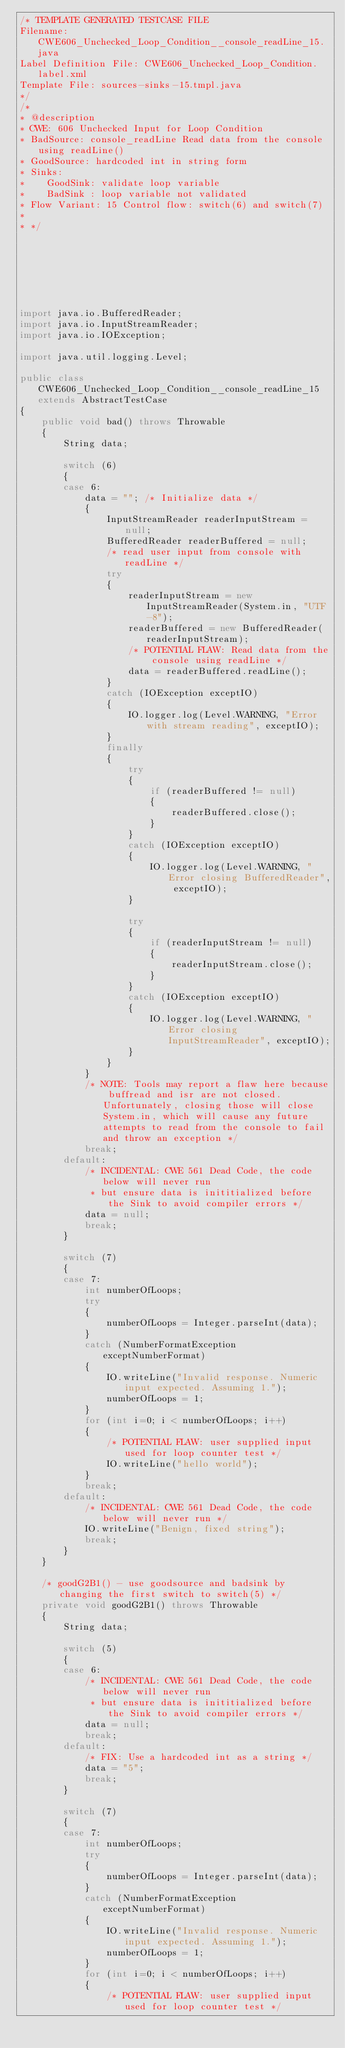Convert code to text. <code><loc_0><loc_0><loc_500><loc_500><_Java_>/* TEMPLATE GENERATED TESTCASE FILE
Filename: CWE606_Unchecked_Loop_Condition__console_readLine_15.java
Label Definition File: CWE606_Unchecked_Loop_Condition.label.xml
Template File: sources-sinks-15.tmpl.java
*/
/*
* @description
* CWE: 606 Unchecked Input for Loop Condition
* BadSource: console_readLine Read data from the console using readLine()
* GoodSource: hardcoded int in string form
* Sinks:
*    GoodSink: validate loop variable
*    BadSink : loop variable not validated
* Flow Variant: 15 Control flow: switch(6) and switch(7)
*
* */







import java.io.BufferedReader;
import java.io.InputStreamReader;
import java.io.IOException;

import java.util.logging.Level;

public class CWE606_Unchecked_Loop_Condition__console_readLine_15 extends AbstractTestCase
{
    public void bad() throws Throwable
    {
        String data;

        switch (6)
        {
        case 6:
            data = ""; /* Initialize data */
            {
                InputStreamReader readerInputStream = null;
                BufferedReader readerBuffered = null;
                /* read user input from console with readLine */
                try
                {
                    readerInputStream = new InputStreamReader(System.in, "UTF-8");
                    readerBuffered = new BufferedReader(readerInputStream);
                    /* POTENTIAL FLAW: Read data from the console using readLine */
                    data = readerBuffered.readLine();
                }
                catch (IOException exceptIO)
                {
                    IO.logger.log(Level.WARNING, "Error with stream reading", exceptIO);
                }
                finally
                {
                    try
                    {
                        if (readerBuffered != null)
                        {
                            readerBuffered.close();
                        }
                    }
                    catch (IOException exceptIO)
                    {
                        IO.logger.log(Level.WARNING, "Error closing BufferedReader", exceptIO);
                    }

                    try
                    {
                        if (readerInputStream != null)
                        {
                            readerInputStream.close();
                        }
                    }
                    catch (IOException exceptIO)
                    {
                        IO.logger.log(Level.WARNING, "Error closing InputStreamReader", exceptIO);
                    }
                }
            }
            /* NOTE: Tools may report a flaw here because buffread and isr are not closed.  Unfortunately, closing those will close System.in, which will cause any future attempts to read from the console to fail and throw an exception */
            break;
        default:
            /* INCIDENTAL: CWE 561 Dead Code, the code below will never run
             * but ensure data is inititialized before the Sink to avoid compiler errors */
            data = null;
            break;
        }

        switch (7)
        {
        case 7:
            int numberOfLoops;
            try
            {
                numberOfLoops = Integer.parseInt(data);
            }
            catch (NumberFormatException exceptNumberFormat)
            {
                IO.writeLine("Invalid response. Numeric input expected. Assuming 1.");
                numberOfLoops = 1;
            }
            for (int i=0; i < numberOfLoops; i++)
            {
                /* POTENTIAL FLAW: user supplied input used for loop counter test */
                IO.writeLine("hello world");
            }
            break;
        default:
            /* INCIDENTAL: CWE 561 Dead Code, the code below will never run */
            IO.writeLine("Benign, fixed string");
            break;
        }
    }

    /* goodG2B1() - use goodsource and badsink by changing the first switch to switch(5) */
    private void goodG2B1() throws Throwable
    {
        String data;

        switch (5)
        {
        case 6:
            /* INCIDENTAL: CWE 561 Dead Code, the code below will never run
             * but ensure data is inititialized before the Sink to avoid compiler errors */
            data = null;
            break;
        default:
            /* FIX: Use a hardcoded int as a string */
            data = "5";
            break;
        }

        switch (7)
        {
        case 7:
            int numberOfLoops;
            try
            {
                numberOfLoops = Integer.parseInt(data);
            }
            catch (NumberFormatException exceptNumberFormat)
            {
                IO.writeLine("Invalid response. Numeric input expected. Assuming 1.");
                numberOfLoops = 1;
            }
            for (int i=0; i < numberOfLoops; i++)
            {
                /* POTENTIAL FLAW: user supplied input used for loop counter test */</code> 